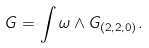Convert formula to latex. <formula><loc_0><loc_0><loc_500><loc_500>G = \int \omega \wedge G _ { ( 2 , 2 , 0 ) } .</formula> 